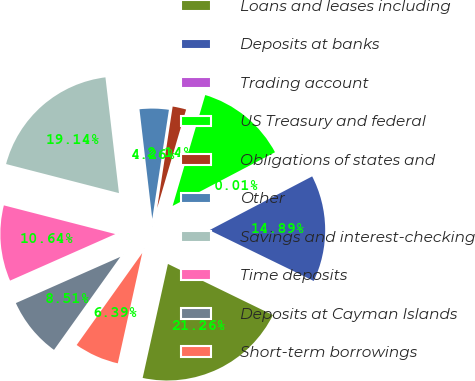Convert chart to OTSL. <chart><loc_0><loc_0><loc_500><loc_500><pie_chart><fcel>Loans and leases including<fcel>Deposits at banks<fcel>Trading account<fcel>US Treasury and federal<fcel>Obligations of states and<fcel>Other<fcel>Savings and interest-checking<fcel>Time deposits<fcel>Deposits at Cayman Islands<fcel>Short-term borrowings<nl><fcel>21.26%<fcel>14.89%<fcel>0.01%<fcel>12.76%<fcel>2.14%<fcel>4.26%<fcel>19.14%<fcel>10.64%<fcel>8.51%<fcel>6.39%<nl></chart> 